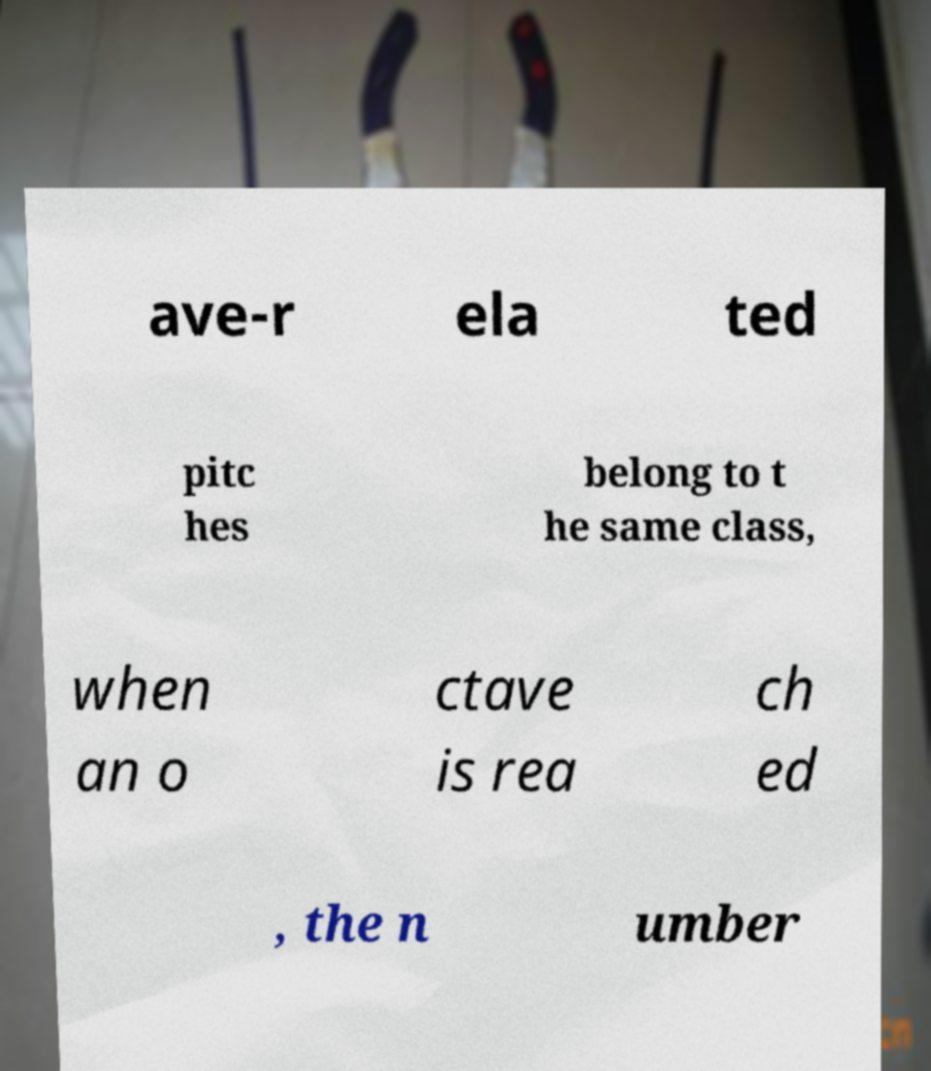Could you assist in decoding the text presented in this image and type it out clearly? ave-r ela ted pitc hes belong to t he same class, when an o ctave is rea ch ed , the n umber 